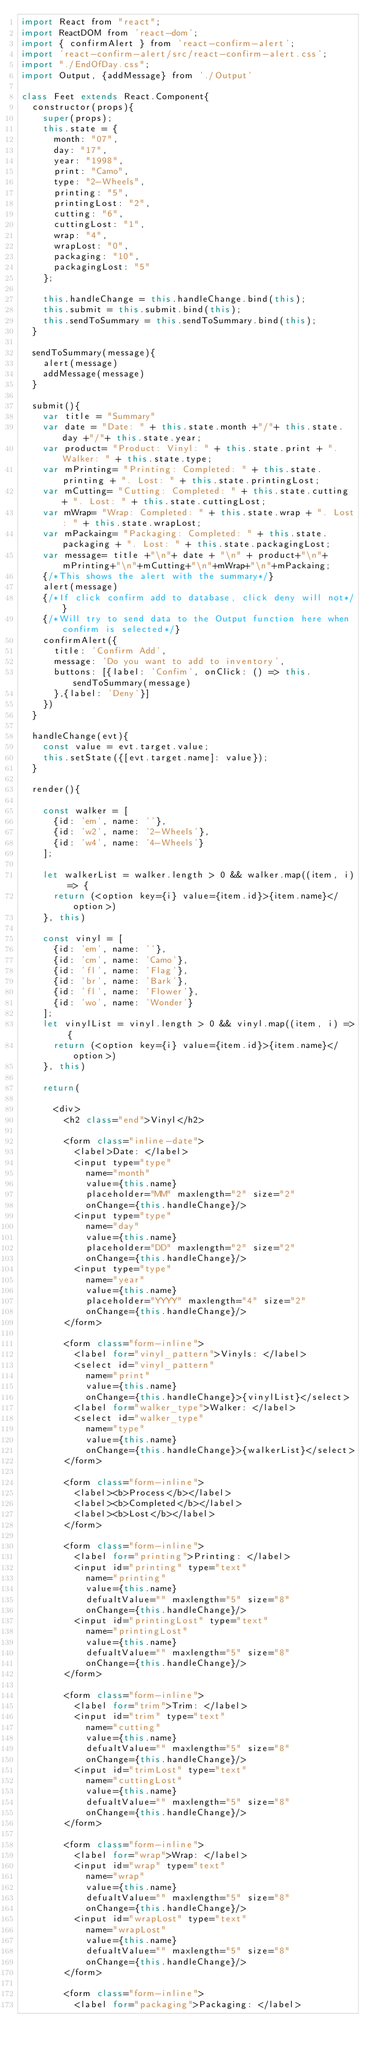Convert code to text. <code><loc_0><loc_0><loc_500><loc_500><_JavaScript_>import React from "react";
import ReactDOM from 'react-dom';
import { confirmAlert } from 'react-confirm-alert';
import 'react-confirm-alert/src/react-confirm-alert.css';
import "./EndOfDay.css";
import Output, {addMessage} from './Output'

class Feet extends React.Component{
  constructor(props){
    super(props);
    this.state = {
      month: "07",
      day: "17",
      year: "1998",
      print: "Camo",
      type: "2-Wheels",
      printing: "5",
      printingLost: "2",
      cutting: "6",
      cuttingLost: "1",
      wrap: "4",
      wrapLost: "0",
      packaging: "10",
      packagingLost: "5"
    };

    this.handleChange = this.handleChange.bind(this);
    this.submit = this.submit.bind(this);
    this.sendToSummary = this.sendToSummary.bind(this);
  }

  sendToSummary(message){
    alert(message)
    addMessage(message)
  }

  submit(){
    var title = "Summary"
    var date = "Date: " + this.state.month +"/"+ this.state.day +"/"+ this.state.year;
    var product= "Product: Vinyl: " + this.state.print + ". Walker: " + this.state.type;
    var mPrinting= "Printing: Completed: " + this.state.printing + ". Lost: " + this.state.printingLost;
    var mCutting= "Cutting: Completed: " + this.state.cutting + ". Lost: " + this.state.cuttingLost;
    var mWrap= "Wrap: Completed: " + this.state.wrap + ". Lost: " + this.state.wrapLost;
    var mPackaing= "Packaging: Completed: " + this.state.packaging + ". Lost: " + this.state.packagingLost;
    var message= title +"\n"+ date + "\n" + product+"\n"+mPrinting+"\n"+mCutting+"\n"+mWrap+"\n"+mPackaing;
    {/*This shows the alert with the summary*/}
    alert(message)
    {/*If click confirm add to database, click deny will not*/}
    {/*Will try to send data to the Output function here when confirm is selected*/}
    confirmAlert({
      title: 'Confirm Add',
      message: 'Do you want to add to inventory',
      buttons: [{label: 'Confim', onClick: () => this.sendToSummary(message)
      },{label: 'Deny'}]
    })
  }

  handleChange(evt){
    const value = evt.target.value;
    this.setState({[evt.target.name]: value});
  }

  render(){

    const walker = [
      {id: 'em', name: ''},
      {id: 'w2', name: '2-Wheels'},
      {id: 'w4', name: '4-Wheels'}
    ];

    let walkerList = walker.length > 0 && walker.map((item, i) => {
      return (<option key={i} value={item.id}>{item.name}</option>)
    }, this)

    const vinyl = [
      {id: 'em', name: ''},
      {id: 'cm', name: 'Camo'},
      {id: 'fl', name: 'Flag'},
      {id: 'br', name: 'Bark'},
      {id: 'fl', name: 'Flower'},
      {id: 'wo', name: 'Wonder'}
    ];
    let vinylList = vinyl.length > 0 && vinyl.map((item, i) => {
      return (<option key={i} value={item.id}>{item.name}</option>)
    }, this)

    return(

      <div>
        <h2 class="end">Vinyl</h2>

        <form class="inline-date">
          <label>Date: </label>
          <input type="type"
            name="month"
            value={this.name}
            placeholder="MM" maxlength="2" size="2"
            onChange={this.handleChange}/>
          <input type="type"
            name="day"
            value={this.name}
            placeholder="DD" maxlength="2" size="2"
            onChange={this.handleChange}/>
          <input type="type"
            name="year"
            value={this.name}
            placeholder="YYYY" maxlength="4" size="2"
            onChange={this.handleChange}/>
        </form>

        <form class="form-inline">
          <label for="vinyl_pattern">Vinyls: </label>
          <select id="vinyl_pattern"
            name="print"
            value={this.name}
            onChange={this.handleChange}>{vinylList}</select>
          <label for="walker_type">Walker: </label>
          <select id="walker_type"
            name="type"
            value={this.name}
            onChange={this.handleChange}>{walkerList}</select>
        </form>

        <form class="form-inline">
          <label><b>Process</b></label>
          <label><b>Completed</b></label>
          <label><b>Lost</b></label>
        </form>

        <form class="form-inline">
          <label for="printing">Printing: </label>
          <input id="printing" type="text"
            name="printing"
            value={this.name}
            defualtValue="" maxlength="5" size="8"
            onChange={this.handleChange}/>
          <input id="printingLost" type="text"
            name="printingLost"
            value={this.name}
            defualtValue="" maxlength="5" size="8"
            onChange={this.handleChange}/>
        </form>

        <form class="form-inline">
          <label for="trim">Trim: </label>
          <input id="trim" type="text"
            name="cutting"
            value={this.name}
            defualtValue="" maxlength="5" size="8"
            onChange={this.handleChange}/>
          <input id="trimLost" type="text"
            name="cuttingLost"
            value={this.name}
            defualtValue="" maxlength="5" size="8"
            onChange={this.handleChange}/>
        </form>

        <form class="form-inline">
          <label for="wrap">Wrap: </label>
          <input id="wrap" type="text"
            name="wrap"
            value={this.name}
            defualtValue="" maxlength="5" size="8"
            onChange={this.handleChange}/>
          <input id="wrapLost" type="text"
            name="wrapLost"
            value={this.name}
            defualtValue="" maxlength="5" size="8"
            onChange={this.handleChange}/>
        </form>

        <form class="form-inline">
          <label for="packaging">Packaging: </label></code> 